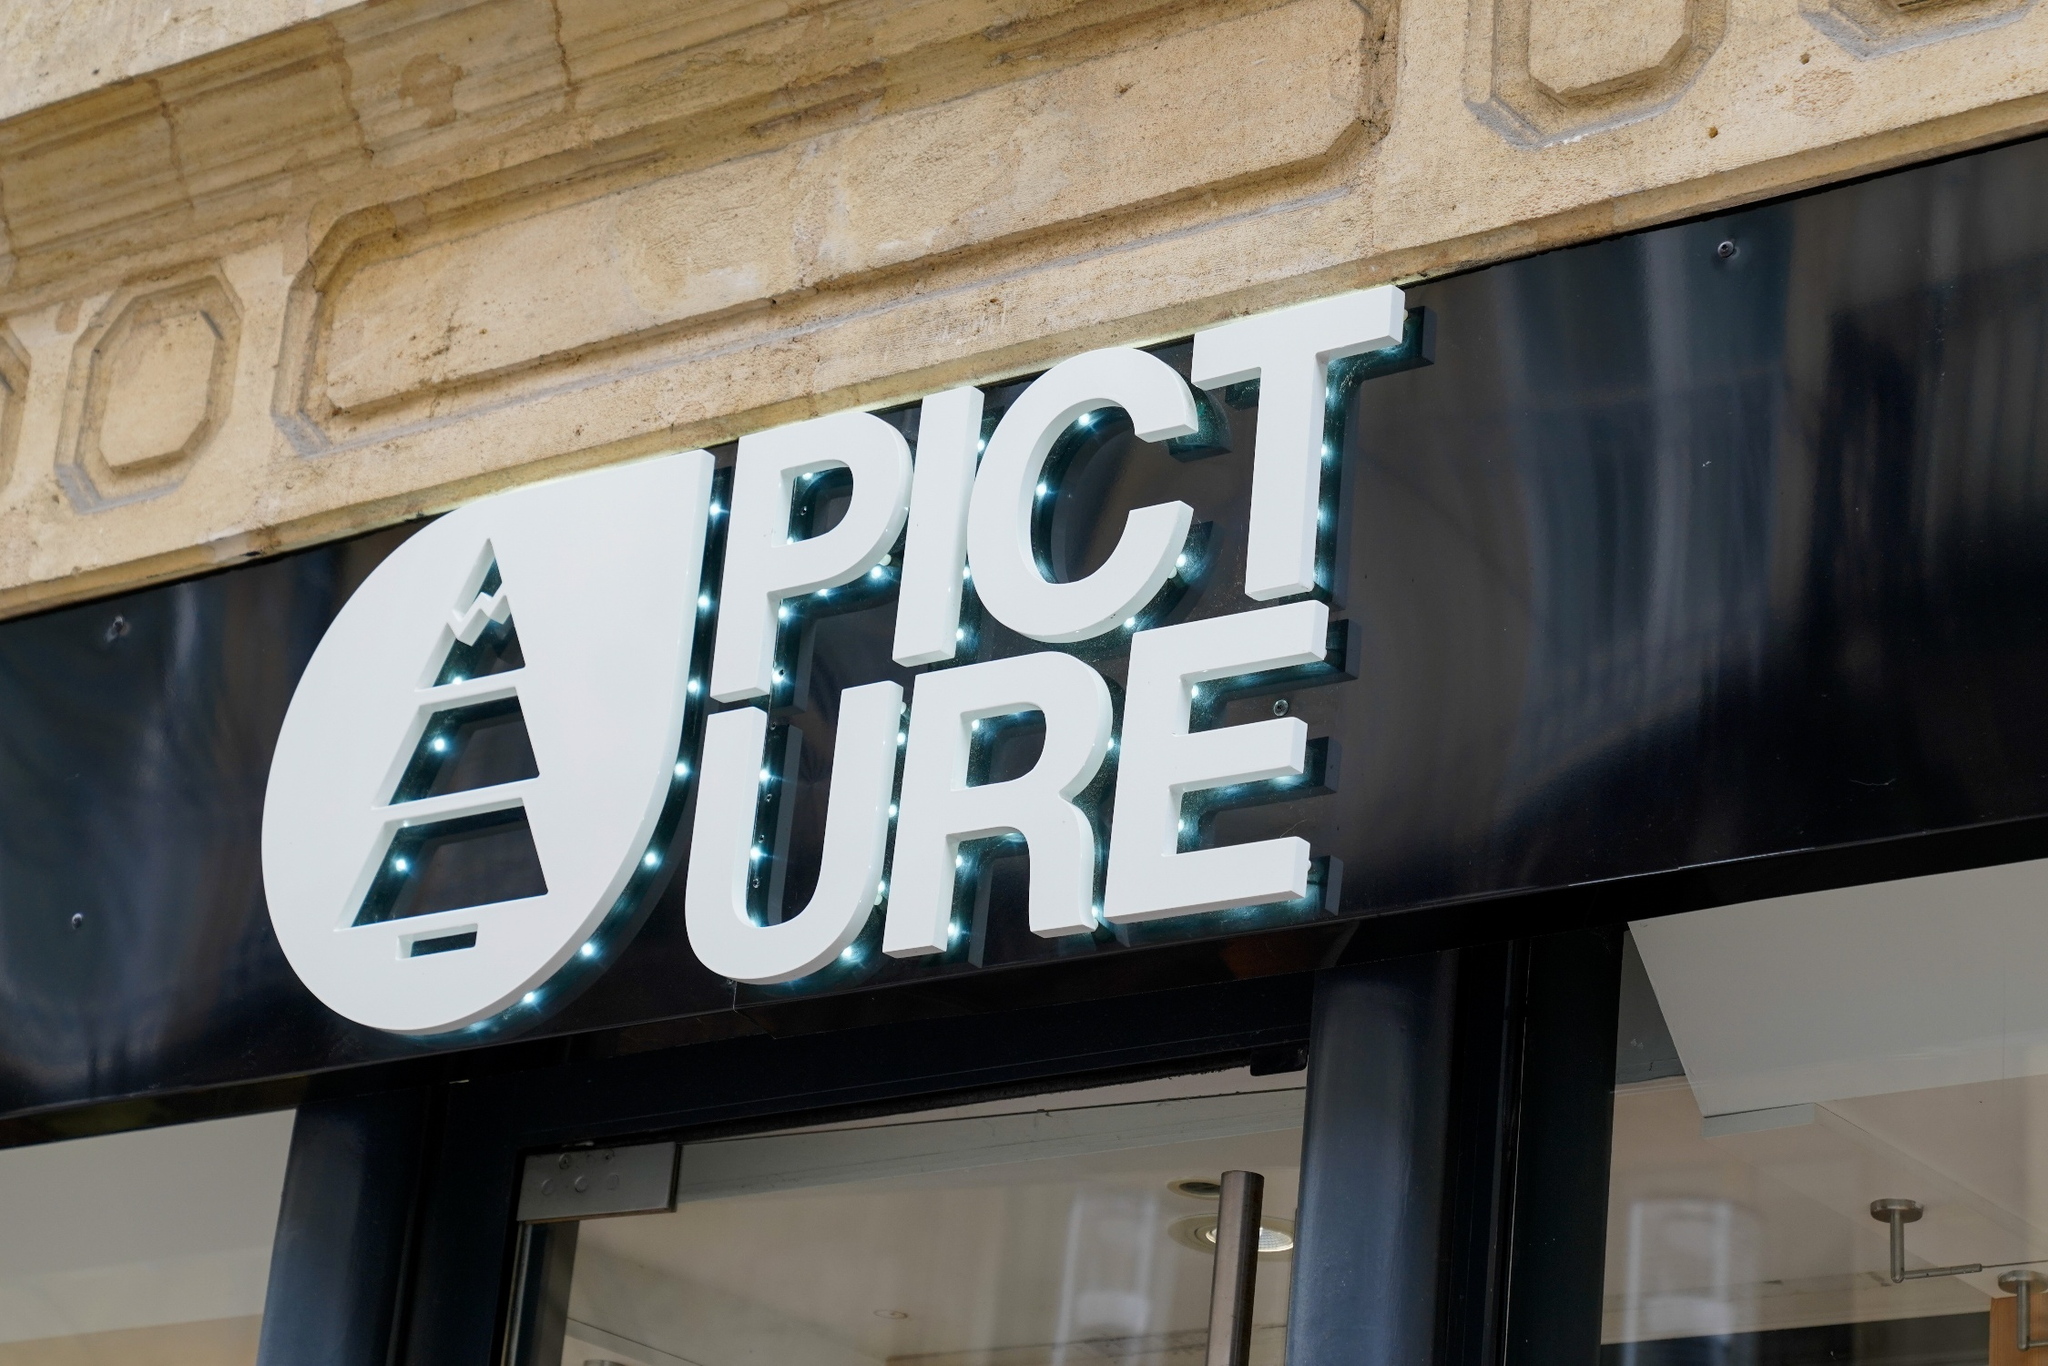If you were to imagine a story happening here, what would it be? Imagine a quiet afternoon in a charming European town. The shop 'PICTURE' has just opened for the day. The owner, a passionate photographer named Alex, is eagerly anticipating displaying their latest collection of photographs inspired by local landscapes. Early morning light filters through the glass door, casting soft shadows that dance on the stone facade. As customers step inside, they're greeted by warm, ambient lighting and a gallery-like interior, where each photograph narrates a unique story of the town’s hidden gems. What could be the main attraction inside this store? The main attraction inside the store could be an exclusive photography exhibition. This exhibition might feature a series of meticulously curated images capturing the essence of urban and natural landscapes from around the world. Each photograph could be accompanied by a captivating backstory, providing visitors with a deeper connection to the art. Additionally, the store might offer limited edition prints and photography books, turning the visit into an enriching cultural experience. If the store transformed at night, how would it look? As night falls, 'PICTURE' transforms into a vibrant spot illuminated by soft, ambient lighting. The turquoise outline of the sign glows warmly against the dark night sky, inviting passersby with its gentle allure. Inside, candles and spotlights create an intimate atmosphere, highlighting the photographs in a dramatic play of light and shadow. The store’s vibe turns cozy and inspiring, making it a perfect venue for evening gallery shows, artist meet-and-greet sessions, and perhaps even photography workshops under the starlit sky reflected through the glass door. 